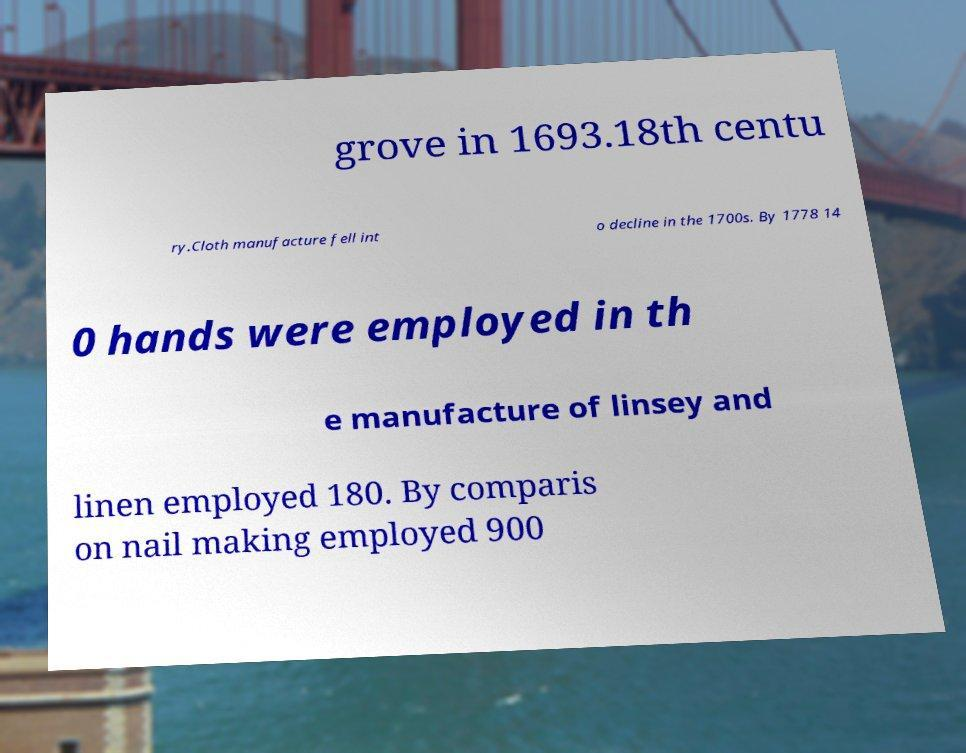Please read and relay the text visible in this image. What does it say? grove in 1693.18th centu ry.Cloth manufacture fell int o decline in the 1700s. By 1778 14 0 hands were employed in th e manufacture of linsey and linen employed 180. By comparis on nail making employed 900 